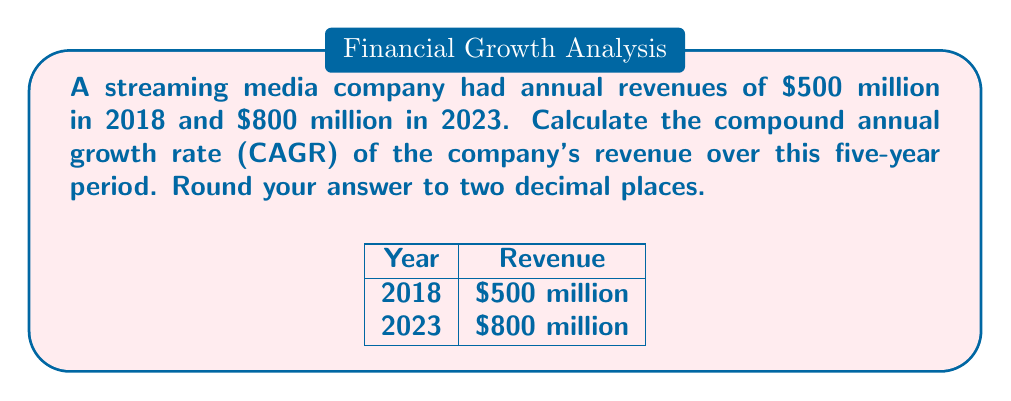Help me with this question. To calculate the CAGR, we'll use the formula:

$$ CAGR = \left(\frac{Ending Value}{Beginning Value}\right)^{\frac{1}{n}} - 1 $$

Where:
- Ending Value = $800 million (2023 revenue)
- Beginning Value = $500 million (2018 revenue)
- n = 5 years

Let's substitute these values into the formula:

$$ CAGR = \left(\frac{800}{500}\right)^{\frac{1}{5}} - 1 $$

Now, let's solve step-by-step:

1) First, calculate the fraction inside the parentheses:
   $\frac{800}{500} = 1.6$

2) Now, our equation looks like this:
   $$ CAGR = (1.6)^{\frac{1}{5}} - 1 $$

3) Calculate the fifth root of 1.6:
   $(1.6)^{\frac{1}{5}} \approx 1.0986$

4) Subtract 1:
   $1.0986 - 1 = 0.0986$

5) Convert to a percentage by multiplying by 100:
   $0.0986 * 100 = 9.86\%$

6) Round to two decimal places:
   $9.86\%$

Therefore, the CAGR of the company's revenue over the five-year period is 9.86%.
Answer: 9.86% 